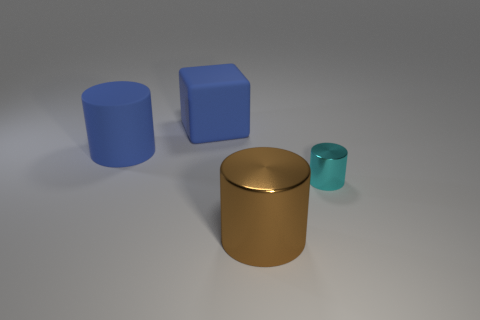There is a large matte thing that is the same color as the large cube; what is its shape?
Offer a terse response. Cylinder. There is a tiny thing that is the same shape as the large metallic thing; what is its color?
Provide a succinct answer. Cyan. Is there a tiny cyan metal thing that has the same shape as the brown metal object?
Ensure brevity in your answer.  Yes. Are there the same number of big brown metal objects on the right side of the small cyan object and small shiny things?
Provide a succinct answer. No. Does the blue matte cube have the same size as the shiny object that is in front of the tiny cyan metallic cylinder?
Your response must be concise. Yes. How many other large blocks have the same material as the big blue cube?
Your response must be concise. 0. Is the blue cylinder the same size as the brown metallic thing?
Your answer should be very brief. Yes. Are there any other things that are the same color as the large block?
Your answer should be very brief. Yes. The thing that is both in front of the rubber cylinder and on the left side of the cyan cylinder has what shape?
Offer a terse response. Cylinder. There is a thing that is right of the big metal thing; how big is it?
Make the answer very short. Small. 